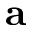<formula> <loc_0><loc_0><loc_500><loc_500>a</formula> 